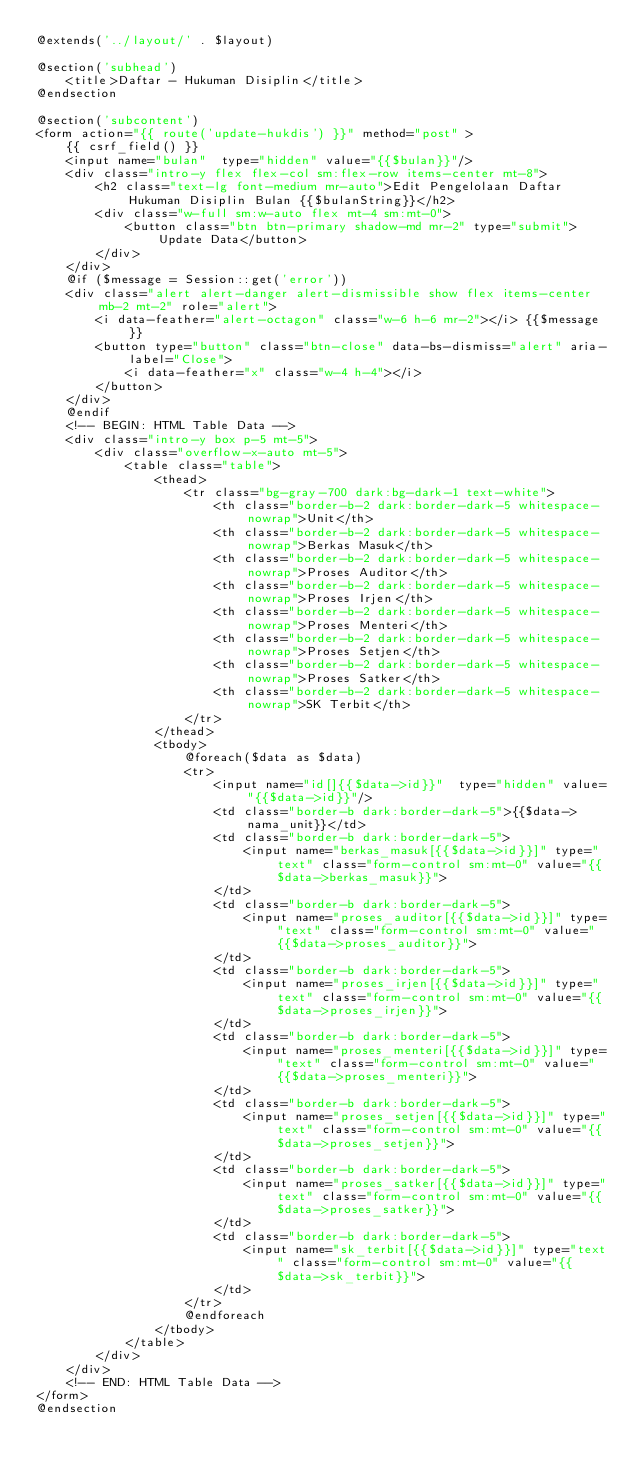Convert code to text. <code><loc_0><loc_0><loc_500><loc_500><_PHP_>@extends('../layout/' . $layout)

@section('subhead')
    <title>Daftar - Hukuman Disiplin</title>
@endsection

@section('subcontent')
<form action="{{ route('update-hukdis') }}" method="post" >  
    {{ csrf_field() }}
    <input name="bulan"  type="hidden" value="{{$bulan}}"/>
    <div class="intro-y flex flex-col sm:flex-row items-center mt-8">
        <h2 class="text-lg font-medium mr-auto">Edit Pengelolaan Daftar Hukuman Disiplin Bulan {{$bulanString}}</h2>
        <div class="w-full sm:w-auto flex mt-4 sm:mt-0">
            <button class="btn btn-primary shadow-md mr-2" type="submit">Update Data</button>
        </div>
    </div>
    @if ($message = Session::get('error'))
    <div class="alert alert-danger alert-dismissible show flex items-center mb-2 mt-2" role="alert">
        <i data-feather="alert-octagon" class="w-6 h-6 mr-2"></i> {{$message}}
        <button type="button" class="btn-close" data-bs-dismiss="alert" aria-label="Close">
            <i data-feather="x" class="w-4 h-4"></i>
        </button>
    </div>
    @endif
    <!-- BEGIN: HTML Table Data -->
    <div class="intro-y box p-5 mt-5">                                    
        <div class="overflow-x-auto mt-5">
            <table class="table">
                <thead>
                    <tr class="bg-gray-700 dark:bg-dark-1 text-white">
                        <th class="border-b-2 dark:border-dark-5 whitespace-nowrap">Unit</th>
                        <th class="border-b-2 dark:border-dark-5 whitespace-nowrap">Berkas Masuk</th>
                        <th class="border-b-2 dark:border-dark-5 whitespace-nowrap">Proses Auditor</th>
                        <th class="border-b-2 dark:border-dark-5 whitespace-nowrap">Proses Irjen</th>
                        <th class="border-b-2 dark:border-dark-5 whitespace-nowrap">Proses Menteri</th>
                        <th class="border-b-2 dark:border-dark-5 whitespace-nowrap">Proses Setjen</th>
                        <th class="border-b-2 dark:border-dark-5 whitespace-nowrap">Proses Satker</th>
                        <th class="border-b-2 dark:border-dark-5 whitespace-nowrap">SK Terbit</th>
                    </tr>
                </thead>
                <tbody>
                    @foreach($data as $data)
                    <tr>
                        <input name="id[]{{$data->id}}"  type="hidden" value="{{$data->id}}"/>
                        <td class="border-b dark:border-dark-5">{{$data->nama_unit}}</td>
                        <td class="border-b dark:border-dark-5">
                            <input name="berkas_masuk[{{$data->id}}]" type="text" class="form-control sm:mt-0" value="{{$data->berkas_masuk}}">
                        </td>
                        <td class="border-b dark:border-dark-5">
                            <input name="proses_auditor[{{$data->id}}]" type="text" class="form-control sm:mt-0" value="{{$data->proses_auditor}}">
                        </td>
                        <td class="border-b dark:border-dark-5">
                            <input name="proses_irjen[{{$data->id}}]" type="text" class="form-control sm:mt-0" value="{{$data->proses_irjen}}">
                        </td>
                        <td class="border-b dark:border-dark-5">
                            <input name="proses_menteri[{{$data->id}}]" type="text" class="form-control sm:mt-0" value="{{$data->proses_menteri}}">
                        </td>
                        <td class="border-b dark:border-dark-5">
                            <input name="proses_setjen[{{$data->id}}]" type="text" class="form-control sm:mt-0" value="{{$data->proses_setjen}}">
                        </td>
                        <td class="border-b dark:border-dark-5">
                            <input name="proses_satker[{{$data->id}}]" type="text" class="form-control sm:mt-0" value="{{$data->proses_satker}}">
                        </td>
                        <td class="border-b dark:border-dark-5">
                            <input name="sk_terbit[{{$data->id}}]" type="text" class="form-control sm:mt-0" value="{{$data->sk_terbit}}">
                        </td>
                    </tr>
                    @endforeach
                </tbody>
            </table>
        </div>
    </div>
    <!-- END: HTML Table Data -->
</form>
@endsection</code> 